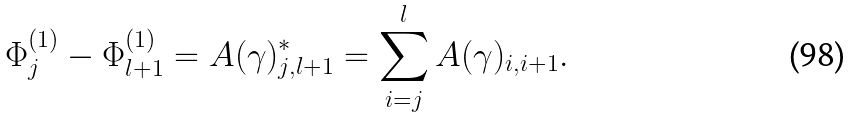Convert formula to latex. <formula><loc_0><loc_0><loc_500><loc_500>\Phi ^ { ( 1 ) } _ { j } - \Phi ^ { ( 1 ) } _ { l + 1 } = A ( \gamma ) ^ { * } _ { j , l + 1 } = \sum _ { i = j } ^ { l } A ( \gamma ) _ { i , i + 1 } .</formula> 